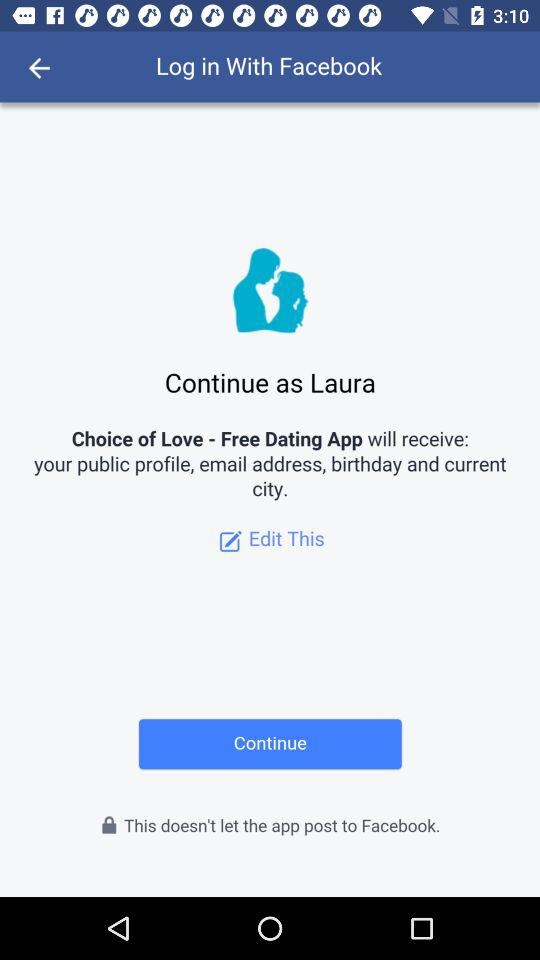What application is asking for permission? The application asking for permission is "Choice of Love - Free Dating App". 